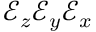Convert formula to latex. <formula><loc_0><loc_0><loc_500><loc_500>\mathcal { E } _ { z } \mathcal { E } _ { y } \mathcal { E } _ { x }</formula> 